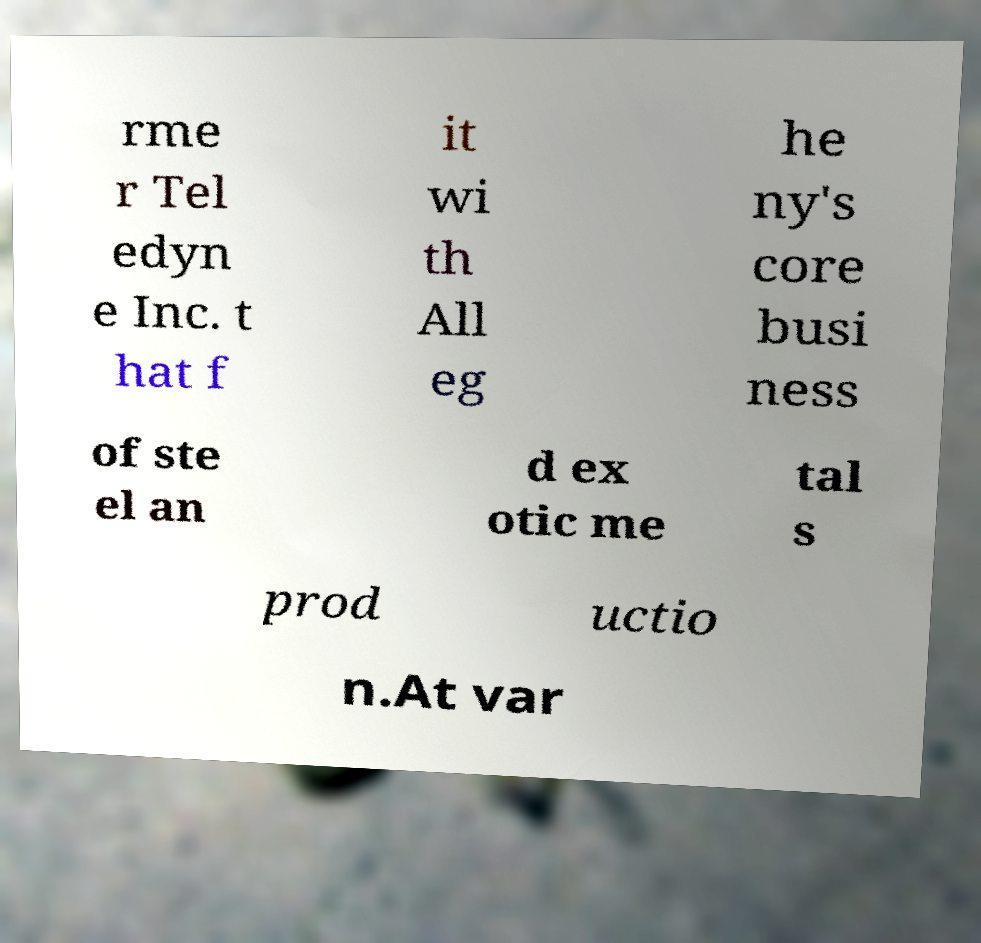For documentation purposes, I need the text within this image transcribed. Could you provide that? rme r Tel edyn e Inc. t hat f it wi th All eg he ny's core busi ness of ste el an d ex otic me tal s prod uctio n.At var 